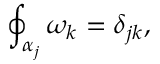<formula> <loc_0><loc_0><loc_500><loc_500>\oint _ { \alpha _ { j } } \omega _ { k } = \delta _ { j k } ,</formula> 